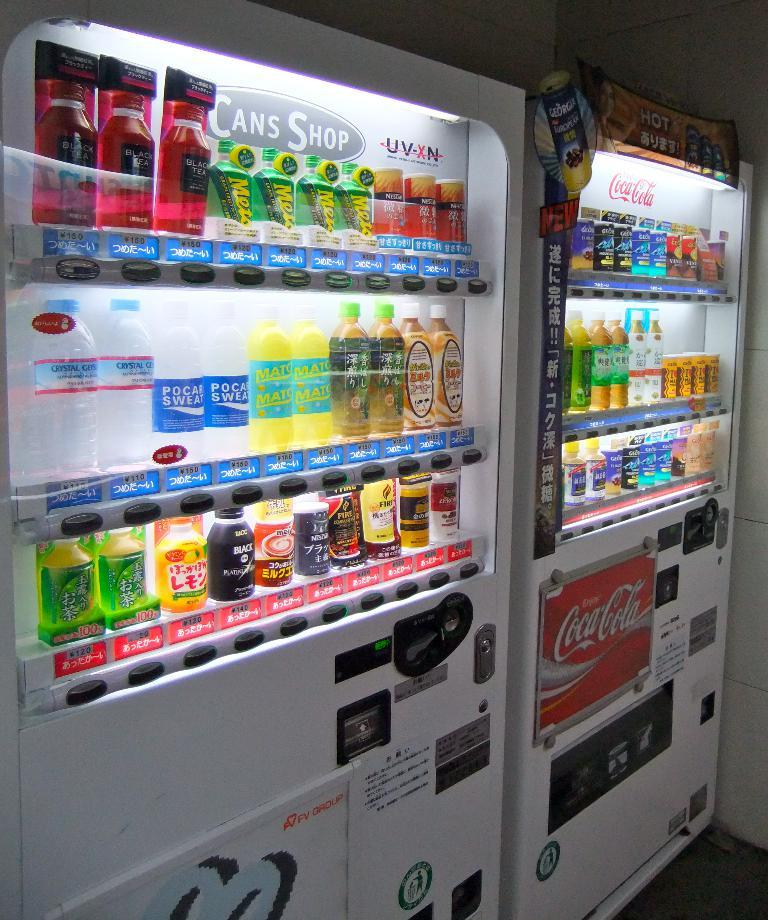<image>
Give a short and clear explanation of the subsequent image. several bottles sit in an area that says cans shop 